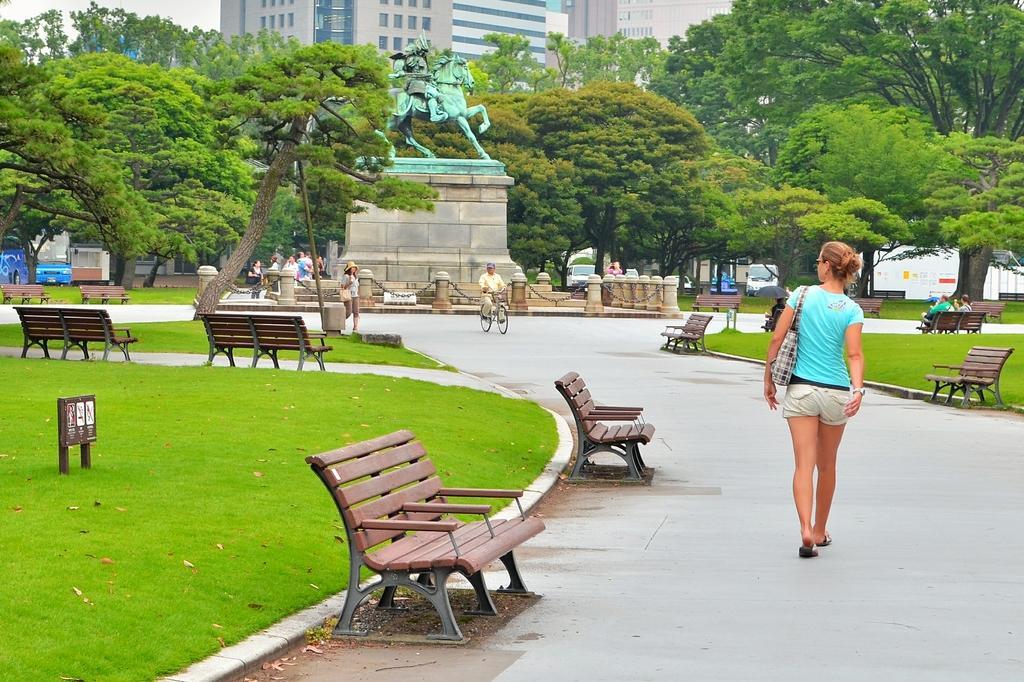How would you summarize this image in a sentence or two? In this Image I see a woman who is on the path and she is carrying a bag and I see few benches and I see the grass. In the background I see few more people and this man on the cycle and I can also see the trees, a statue, few vehicles and the buildings. 